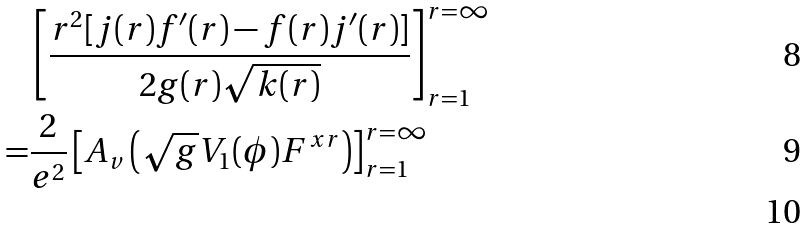Convert formula to latex. <formula><loc_0><loc_0><loc_500><loc_500>& \left [ \frac { r ^ { 2 } [ j ( r ) f ^ { \prime } ( r ) - f ( r ) j ^ { \prime } ( r ) ] } { 2 g ( r ) \sqrt { k ( r ) } } \right ] ^ { r = \infty } _ { r = 1 } \\ = & \frac { 2 } { e ^ { 2 } } \left [ A _ { v } \left ( \sqrt { g } V _ { 1 } ( \phi ) F ^ { x r } \right ) \right ] ^ { r = \infty } _ { r = 1 } \\</formula> 